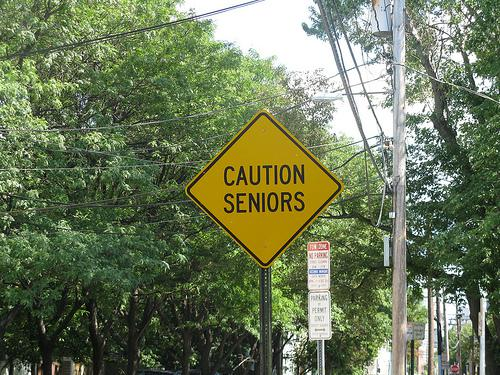Question: where is this photo taken?
Choices:
A. Street.
B. Field.
C. City.
D. Florist.
Answer with the letter. Answer: A Question: what does the yellow sign say?
Choices:
A. Slippery When Wet.
B. Slow Down When Blinking.
C. Wet Floor.
D. Caution seniors.
Answer with the letter. Answer: D Question: what are the green things in the back?
Choices:
A. Plants.
B. Frogs.
C. Trees.
D. Weeds.
Answer with the letter. Answer: C Question: what is the weather like?
Choices:
A. Sunny.
B. Cloudy.
C. Overcast.
D. Stormy.
Answer with the letter. Answer: A Question: what are the cables hanging from the poles?
Choices:
A. Telephone.
B. Electric.
C. Cable tv.
D. Jumper.
Answer with the letter. Answer: B 